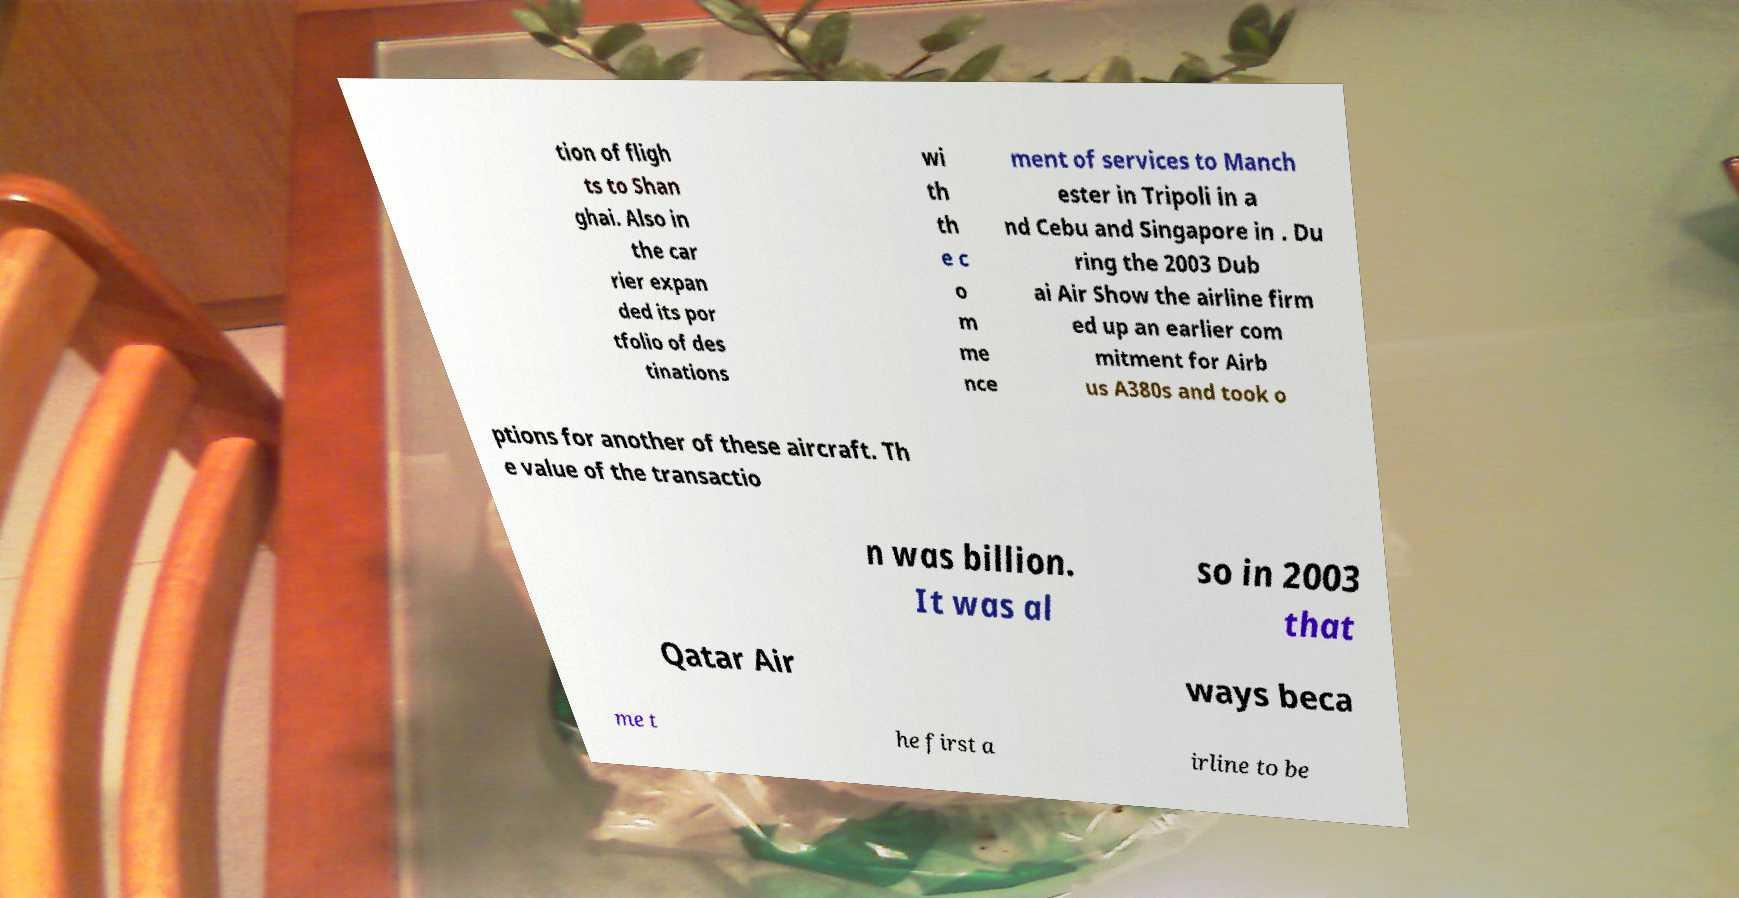Could you extract and type out the text from this image? tion of fligh ts to Shan ghai. Also in the car rier expan ded its por tfolio of des tinations wi th th e c o m me nce ment of services to Manch ester in Tripoli in a nd Cebu and Singapore in . Du ring the 2003 Dub ai Air Show the airline firm ed up an earlier com mitment for Airb us A380s and took o ptions for another of these aircraft. Th e value of the transactio n was billion. It was al so in 2003 that Qatar Air ways beca me t he first a irline to be 